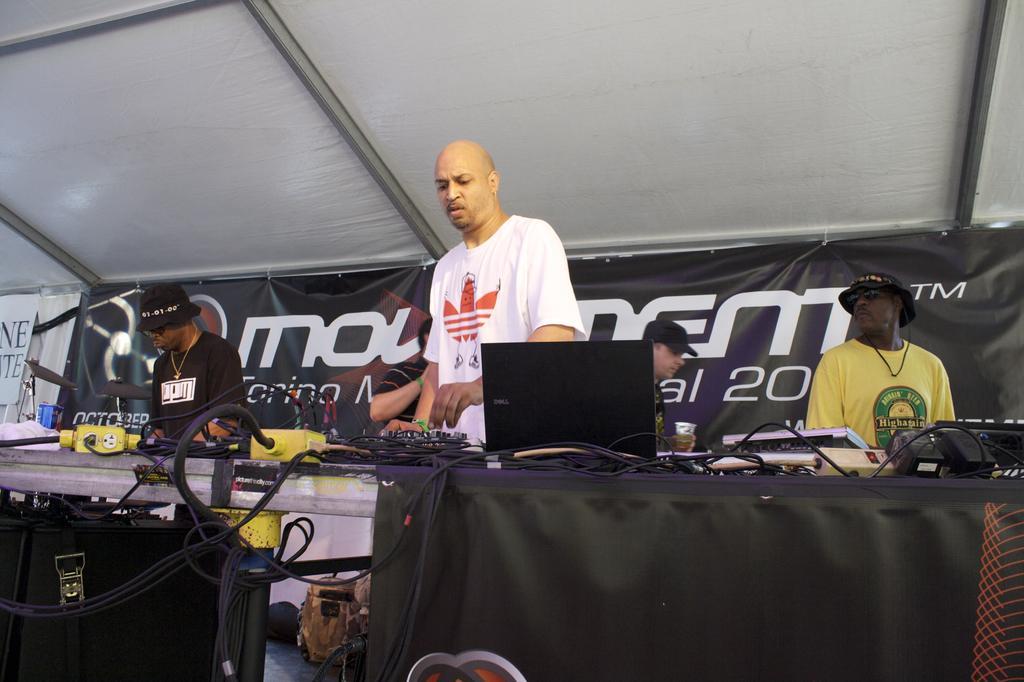How would you summarize this image in a sentence or two? In this picture I can see a table in front, on which there are few electronic equipment and number of wires. Behind the table I can see 5 men standing and in the background I can see banners and on it I see something is written. On the top of this picture I can see the white color cloth and the poles. 